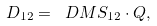<formula> <loc_0><loc_0><loc_500><loc_500>D _ { 1 2 } = \ D M S _ { 1 2 } \cdot Q ,</formula> 